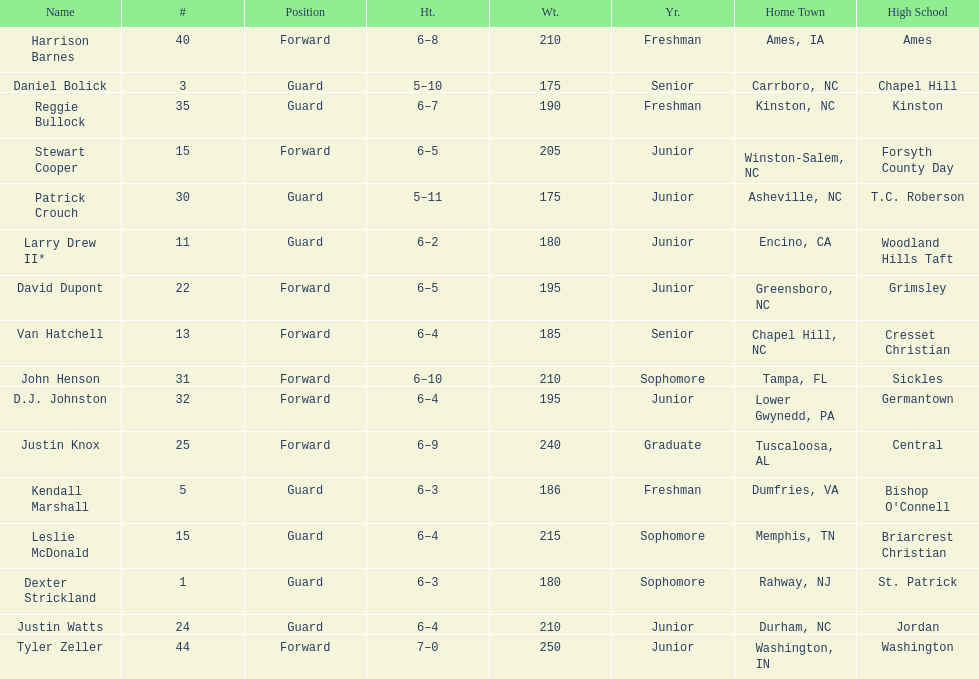Who was taller, justin knox or john henson? John Henson. 